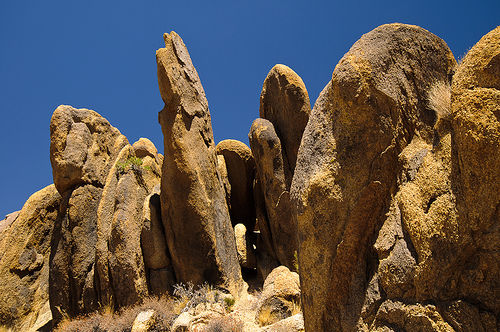<image>
Can you confirm if the sky is on the rock? Yes. Looking at the image, I can see the sky is positioned on top of the rock, with the rock providing support. Is the shadow on the rock? Yes. Looking at the image, I can see the shadow is positioned on top of the rock, with the rock providing support. 